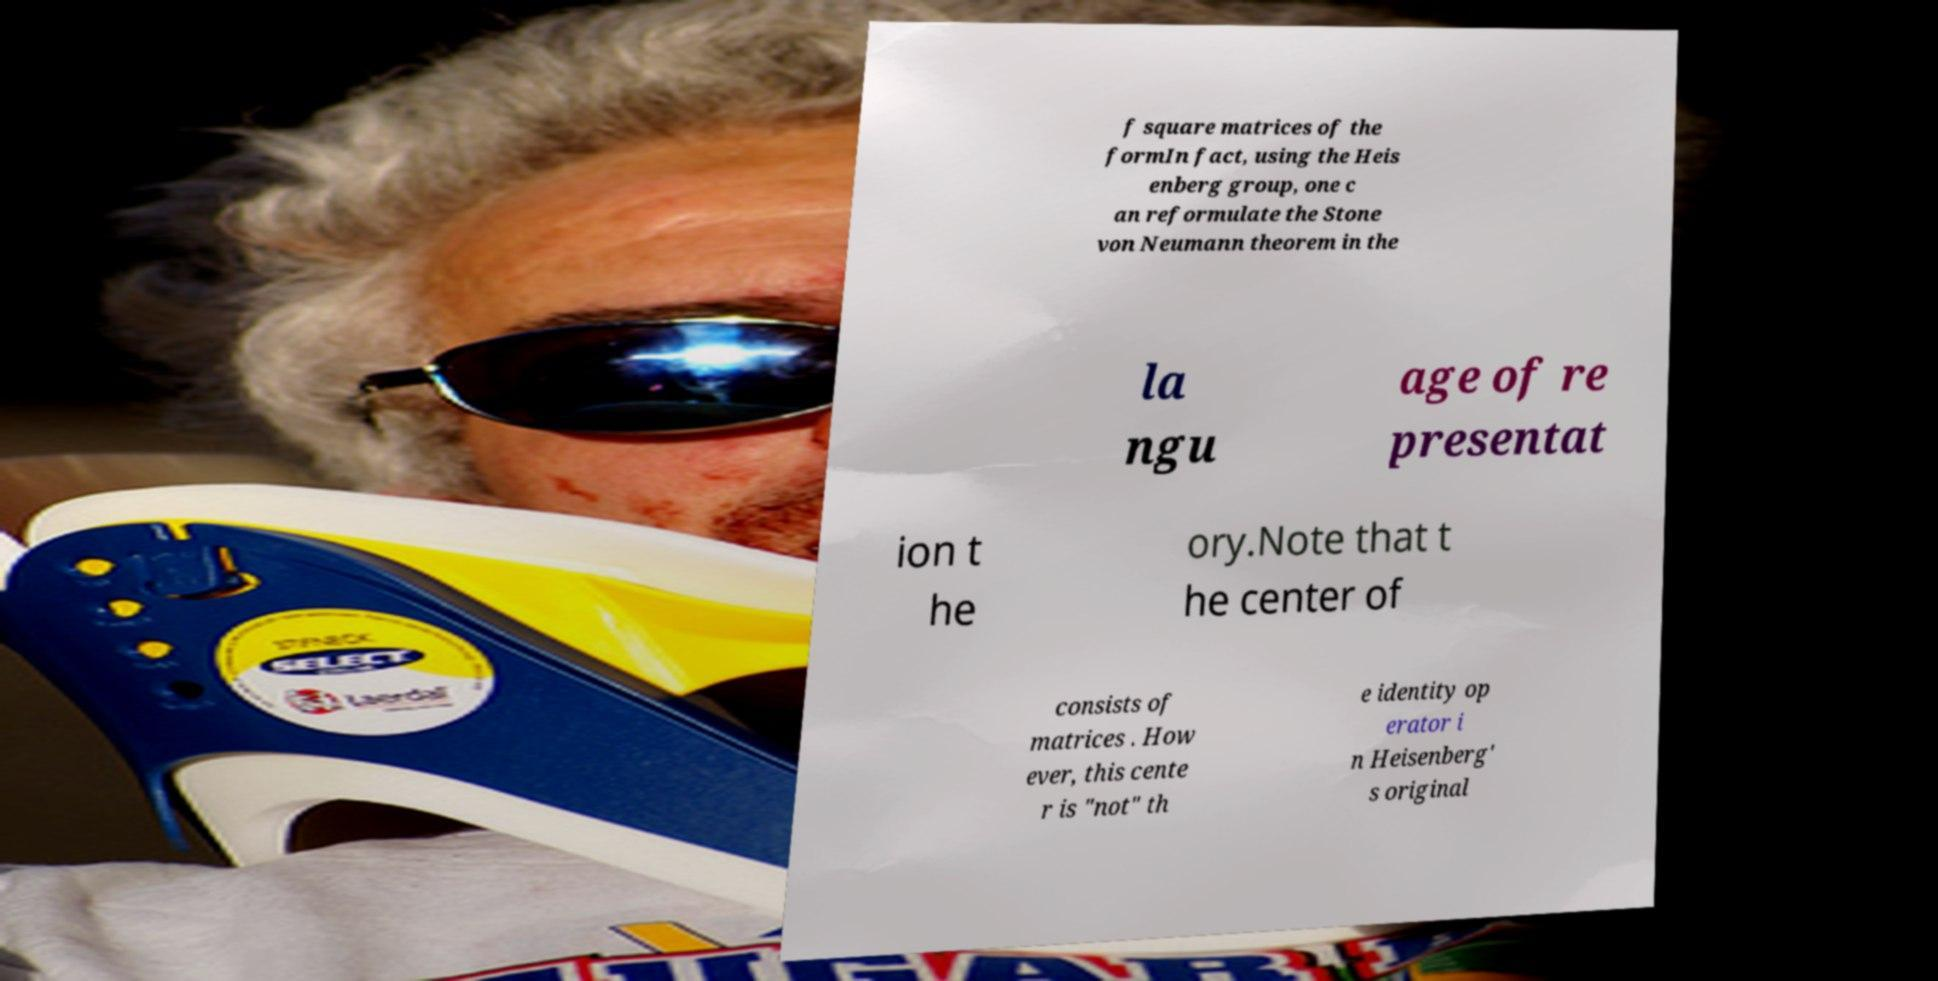Can you read and provide the text displayed in the image?This photo seems to have some interesting text. Can you extract and type it out for me? f square matrices of the formIn fact, using the Heis enberg group, one c an reformulate the Stone von Neumann theorem in the la ngu age of re presentat ion t he ory.Note that t he center of consists of matrices . How ever, this cente r is "not" th e identity op erator i n Heisenberg' s original 